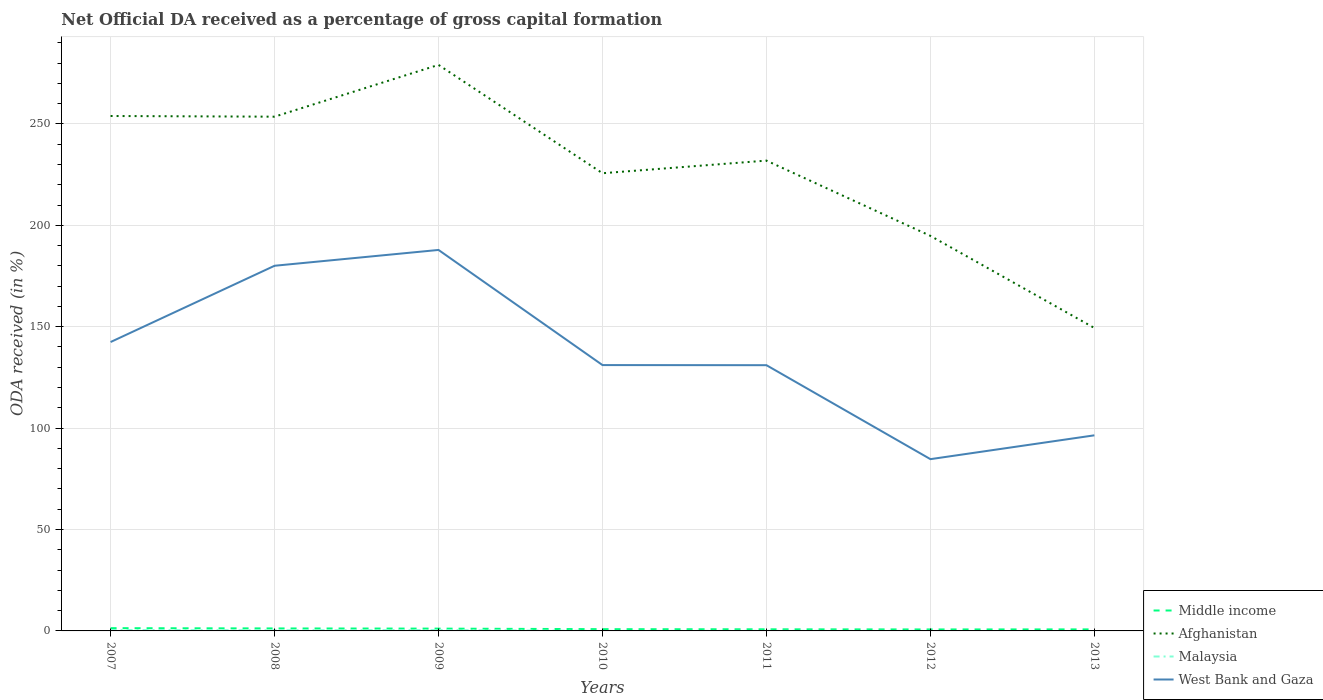Does the line corresponding to Afghanistan intersect with the line corresponding to Malaysia?
Make the answer very short. No. Across all years, what is the maximum net ODA received in Afghanistan?
Make the answer very short. 149.37. What is the total net ODA received in West Bank and Gaza in the graph?
Offer a very short reply. 95.35. What is the difference between the highest and the second highest net ODA received in West Bank and Gaza?
Give a very brief answer. 103.15. What is the difference between the highest and the lowest net ODA received in Malaysia?
Offer a very short reply. 3. Is the net ODA received in Afghanistan strictly greater than the net ODA received in Middle income over the years?
Keep it short and to the point. No. How many lines are there?
Give a very brief answer. 4. How are the legend labels stacked?
Provide a short and direct response. Vertical. What is the title of the graph?
Provide a succinct answer. Net Official DA received as a percentage of gross capital formation. What is the label or title of the X-axis?
Offer a very short reply. Years. What is the label or title of the Y-axis?
Offer a very short reply. ODA received (in %). What is the ODA received (in %) in Middle income in 2007?
Make the answer very short. 1.36. What is the ODA received (in %) in Afghanistan in 2007?
Keep it short and to the point. 253.89. What is the ODA received (in %) in Malaysia in 2007?
Your answer should be very brief. 0.44. What is the ODA received (in %) of West Bank and Gaza in 2007?
Provide a succinct answer. 142.44. What is the ODA received (in %) of Middle income in 2008?
Offer a very short reply. 1.23. What is the ODA received (in %) of Afghanistan in 2008?
Ensure brevity in your answer.  253.56. What is the ODA received (in %) of Malaysia in 2008?
Your response must be concise. 0.31. What is the ODA received (in %) in West Bank and Gaza in 2008?
Give a very brief answer. 180.05. What is the ODA received (in %) of Middle income in 2009?
Make the answer very short. 1.14. What is the ODA received (in %) of Afghanistan in 2009?
Provide a short and direct response. 279.09. What is the ODA received (in %) in Malaysia in 2009?
Give a very brief answer. 0.4. What is the ODA received (in %) of West Bank and Gaza in 2009?
Your response must be concise. 187.84. What is the ODA received (in %) of Middle income in 2010?
Your answer should be compact. 0.87. What is the ODA received (in %) in Afghanistan in 2010?
Your answer should be very brief. 225.67. What is the ODA received (in %) in Malaysia in 2010?
Your response must be concise. 0. What is the ODA received (in %) of West Bank and Gaza in 2010?
Provide a short and direct response. 131.08. What is the ODA received (in %) of Middle income in 2011?
Your answer should be very brief. 0.8. What is the ODA received (in %) in Afghanistan in 2011?
Provide a short and direct response. 231.9. What is the ODA received (in %) in Malaysia in 2011?
Your answer should be very brief. 0.05. What is the ODA received (in %) in West Bank and Gaza in 2011?
Make the answer very short. 131.02. What is the ODA received (in %) in Middle income in 2012?
Provide a succinct answer. 0.73. What is the ODA received (in %) in Afghanistan in 2012?
Provide a succinct answer. 194.79. What is the ODA received (in %) in Malaysia in 2012?
Ensure brevity in your answer.  0.02. What is the ODA received (in %) in West Bank and Gaza in 2012?
Make the answer very short. 84.7. What is the ODA received (in %) of Middle income in 2013?
Provide a succinct answer. 0.76. What is the ODA received (in %) of Afghanistan in 2013?
Offer a terse response. 149.37. What is the ODA received (in %) in West Bank and Gaza in 2013?
Make the answer very short. 96.44. Across all years, what is the maximum ODA received (in %) in Middle income?
Provide a succinct answer. 1.36. Across all years, what is the maximum ODA received (in %) in Afghanistan?
Offer a very short reply. 279.09. Across all years, what is the maximum ODA received (in %) in Malaysia?
Make the answer very short. 0.44. Across all years, what is the maximum ODA received (in %) in West Bank and Gaza?
Provide a succinct answer. 187.84. Across all years, what is the minimum ODA received (in %) of Middle income?
Ensure brevity in your answer.  0.73. Across all years, what is the minimum ODA received (in %) of Afghanistan?
Give a very brief answer. 149.37. Across all years, what is the minimum ODA received (in %) of West Bank and Gaza?
Give a very brief answer. 84.7. What is the total ODA received (in %) of Middle income in the graph?
Provide a short and direct response. 6.88. What is the total ODA received (in %) of Afghanistan in the graph?
Your answer should be compact. 1588.26. What is the total ODA received (in %) of Malaysia in the graph?
Your answer should be very brief. 1.22. What is the total ODA received (in %) of West Bank and Gaza in the graph?
Ensure brevity in your answer.  953.58. What is the difference between the ODA received (in %) in Middle income in 2007 and that in 2008?
Ensure brevity in your answer.  0.13. What is the difference between the ODA received (in %) in Afghanistan in 2007 and that in 2008?
Offer a terse response. 0.33. What is the difference between the ODA received (in %) in Malaysia in 2007 and that in 2008?
Ensure brevity in your answer.  0.13. What is the difference between the ODA received (in %) of West Bank and Gaza in 2007 and that in 2008?
Ensure brevity in your answer.  -37.6. What is the difference between the ODA received (in %) in Middle income in 2007 and that in 2009?
Provide a short and direct response. 0.23. What is the difference between the ODA received (in %) in Afghanistan in 2007 and that in 2009?
Make the answer very short. -25.2. What is the difference between the ODA received (in %) in Malaysia in 2007 and that in 2009?
Give a very brief answer. 0.05. What is the difference between the ODA received (in %) in West Bank and Gaza in 2007 and that in 2009?
Keep it short and to the point. -45.4. What is the difference between the ODA received (in %) of Middle income in 2007 and that in 2010?
Make the answer very short. 0.49. What is the difference between the ODA received (in %) of Afghanistan in 2007 and that in 2010?
Your answer should be very brief. 28.22. What is the difference between the ODA received (in %) in Malaysia in 2007 and that in 2010?
Provide a succinct answer. 0.44. What is the difference between the ODA received (in %) in West Bank and Gaza in 2007 and that in 2010?
Your response must be concise. 11.36. What is the difference between the ODA received (in %) of Middle income in 2007 and that in 2011?
Offer a terse response. 0.57. What is the difference between the ODA received (in %) of Afghanistan in 2007 and that in 2011?
Give a very brief answer. 21.99. What is the difference between the ODA received (in %) of Malaysia in 2007 and that in 2011?
Offer a very short reply. 0.4. What is the difference between the ODA received (in %) of West Bank and Gaza in 2007 and that in 2011?
Provide a succinct answer. 11.42. What is the difference between the ODA received (in %) in Middle income in 2007 and that in 2012?
Make the answer very short. 0.63. What is the difference between the ODA received (in %) of Afghanistan in 2007 and that in 2012?
Your answer should be compact. 59.1. What is the difference between the ODA received (in %) in Malaysia in 2007 and that in 2012?
Offer a very short reply. 0.42. What is the difference between the ODA received (in %) of West Bank and Gaza in 2007 and that in 2012?
Make the answer very short. 57.75. What is the difference between the ODA received (in %) of Middle income in 2007 and that in 2013?
Your response must be concise. 0.6. What is the difference between the ODA received (in %) in Afghanistan in 2007 and that in 2013?
Your response must be concise. 104.52. What is the difference between the ODA received (in %) in West Bank and Gaza in 2007 and that in 2013?
Offer a terse response. 46. What is the difference between the ODA received (in %) of Middle income in 2008 and that in 2009?
Ensure brevity in your answer.  0.09. What is the difference between the ODA received (in %) of Afghanistan in 2008 and that in 2009?
Offer a terse response. -25.53. What is the difference between the ODA received (in %) of Malaysia in 2008 and that in 2009?
Provide a short and direct response. -0.08. What is the difference between the ODA received (in %) in West Bank and Gaza in 2008 and that in 2009?
Keep it short and to the point. -7.8. What is the difference between the ODA received (in %) in Middle income in 2008 and that in 2010?
Make the answer very short. 0.36. What is the difference between the ODA received (in %) in Afghanistan in 2008 and that in 2010?
Your response must be concise. 27.88. What is the difference between the ODA received (in %) in Malaysia in 2008 and that in 2010?
Offer a terse response. 0.31. What is the difference between the ODA received (in %) of West Bank and Gaza in 2008 and that in 2010?
Give a very brief answer. 48.97. What is the difference between the ODA received (in %) of Middle income in 2008 and that in 2011?
Make the answer very short. 0.43. What is the difference between the ODA received (in %) of Afghanistan in 2008 and that in 2011?
Your response must be concise. 21.66. What is the difference between the ODA received (in %) of Malaysia in 2008 and that in 2011?
Keep it short and to the point. 0.27. What is the difference between the ODA received (in %) of West Bank and Gaza in 2008 and that in 2011?
Your answer should be very brief. 49.03. What is the difference between the ODA received (in %) in Middle income in 2008 and that in 2012?
Keep it short and to the point. 0.5. What is the difference between the ODA received (in %) in Afghanistan in 2008 and that in 2012?
Your answer should be compact. 58.77. What is the difference between the ODA received (in %) of Malaysia in 2008 and that in 2012?
Make the answer very short. 0.29. What is the difference between the ODA received (in %) of West Bank and Gaza in 2008 and that in 2012?
Your response must be concise. 95.35. What is the difference between the ODA received (in %) in Middle income in 2008 and that in 2013?
Provide a short and direct response. 0.47. What is the difference between the ODA received (in %) in Afghanistan in 2008 and that in 2013?
Your response must be concise. 104.19. What is the difference between the ODA received (in %) of West Bank and Gaza in 2008 and that in 2013?
Your answer should be compact. 83.61. What is the difference between the ODA received (in %) of Middle income in 2009 and that in 2010?
Ensure brevity in your answer.  0.27. What is the difference between the ODA received (in %) in Afghanistan in 2009 and that in 2010?
Give a very brief answer. 53.42. What is the difference between the ODA received (in %) in Malaysia in 2009 and that in 2010?
Offer a terse response. 0.39. What is the difference between the ODA received (in %) of West Bank and Gaza in 2009 and that in 2010?
Your response must be concise. 56.76. What is the difference between the ODA received (in %) of Middle income in 2009 and that in 2011?
Offer a terse response. 0.34. What is the difference between the ODA received (in %) in Afghanistan in 2009 and that in 2011?
Provide a succinct answer. 47.19. What is the difference between the ODA received (in %) of Malaysia in 2009 and that in 2011?
Your answer should be compact. 0.35. What is the difference between the ODA received (in %) in West Bank and Gaza in 2009 and that in 2011?
Your answer should be compact. 56.82. What is the difference between the ODA received (in %) of Middle income in 2009 and that in 2012?
Provide a succinct answer. 0.4. What is the difference between the ODA received (in %) in Afghanistan in 2009 and that in 2012?
Offer a very short reply. 84.3. What is the difference between the ODA received (in %) of Malaysia in 2009 and that in 2012?
Your answer should be very brief. 0.38. What is the difference between the ODA received (in %) in West Bank and Gaza in 2009 and that in 2012?
Give a very brief answer. 103.15. What is the difference between the ODA received (in %) of Middle income in 2009 and that in 2013?
Your answer should be compact. 0.38. What is the difference between the ODA received (in %) of Afghanistan in 2009 and that in 2013?
Provide a succinct answer. 129.72. What is the difference between the ODA received (in %) of West Bank and Gaza in 2009 and that in 2013?
Offer a terse response. 91.4. What is the difference between the ODA received (in %) in Middle income in 2010 and that in 2011?
Your answer should be very brief. 0.07. What is the difference between the ODA received (in %) of Afghanistan in 2010 and that in 2011?
Your response must be concise. -6.22. What is the difference between the ODA received (in %) in Malaysia in 2010 and that in 2011?
Your answer should be very brief. -0.04. What is the difference between the ODA received (in %) of West Bank and Gaza in 2010 and that in 2011?
Provide a succinct answer. 0.06. What is the difference between the ODA received (in %) in Middle income in 2010 and that in 2012?
Give a very brief answer. 0.14. What is the difference between the ODA received (in %) in Afghanistan in 2010 and that in 2012?
Your response must be concise. 30.89. What is the difference between the ODA received (in %) of Malaysia in 2010 and that in 2012?
Make the answer very short. -0.02. What is the difference between the ODA received (in %) of West Bank and Gaza in 2010 and that in 2012?
Keep it short and to the point. 46.38. What is the difference between the ODA received (in %) of Middle income in 2010 and that in 2013?
Ensure brevity in your answer.  0.11. What is the difference between the ODA received (in %) of Afghanistan in 2010 and that in 2013?
Provide a short and direct response. 76.3. What is the difference between the ODA received (in %) in West Bank and Gaza in 2010 and that in 2013?
Keep it short and to the point. 34.64. What is the difference between the ODA received (in %) in Middle income in 2011 and that in 2012?
Your response must be concise. 0.06. What is the difference between the ODA received (in %) of Afghanistan in 2011 and that in 2012?
Ensure brevity in your answer.  37.11. What is the difference between the ODA received (in %) in Malaysia in 2011 and that in 2012?
Your answer should be very brief. 0.03. What is the difference between the ODA received (in %) in West Bank and Gaza in 2011 and that in 2012?
Provide a succinct answer. 46.32. What is the difference between the ODA received (in %) in Middle income in 2011 and that in 2013?
Keep it short and to the point. 0.04. What is the difference between the ODA received (in %) in Afghanistan in 2011 and that in 2013?
Offer a terse response. 82.53. What is the difference between the ODA received (in %) in West Bank and Gaza in 2011 and that in 2013?
Keep it short and to the point. 34.58. What is the difference between the ODA received (in %) of Middle income in 2012 and that in 2013?
Make the answer very short. -0.03. What is the difference between the ODA received (in %) in Afghanistan in 2012 and that in 2013?
Give a very brief answer. 45.41. What is the difference between the ODA received (in %) of West Bank and Gaza in 2012 and that in 2013?
Your answer should be very brief. -11.75. What is the difference between the ODA received (in %) in Middle income in 2007 and the ODA received (in %) in Afghanistan in 2008?
Your answer should be very brief. -252.19. What is the difference between the ODA received (in %) of Middle income in 2007 and the ODA received (in %) of Malaysia in 2008?
Give a very brief answer. 1.05. What is the difference between the ODA received (in %) in Middle income in 2007 and the ODA received (in %) in West Bank and Gaza in 2008?
Give a very brief answer. -178.69. What is the difference between the ODA received (in %) of Afghanistan in 2007 and the ODA received (in %) of Malaysia in 2008?
Keep it short and to the point. 253.58. What is the difference between the ODA received (in %) of Afghanistan in 2007 and the ODA received (in %) of West Bank and Gaza in 2008?
Keep it short and to the point. 73.84. What is the difference between the ODA received (in %) in Malaysia in 2007 and the ODA received (in %) in West Bank and Gaza in 2008?
Ensure brevity in your answer.  -179.61. What is the difference between the ODA received (in %) in Middle income in 2007 and the ODA received (in %) in Afghanistan in 2009?
Offer a very short reply. -277.73. What is the difference between the ODA received (in %) of Middle income in 2007 and the ODA received (in %) of Malaysia in 2009?
Your answer should be very brief. 0.97. What is the difference between the ODA received (in %) of Middle income in 2007 and the ODA received (in %) of West Bank and Gaza in 2009?
Your answer should be very brief. -186.48. What is the difference between the ODA received (in %) in Afghanistan in 2007 and the ODA received (in %) in Malaysia in 2009?
Your response must be concise. 253.49. What is the difference between the ODA received (in %) of Afghanistan in 2007 and the ODA received (in %) of West Bank and Gaza in 2009?
Give a very brief answer. 66.04. What is the difference between the ODA received (in %) in Malaysia in 2007 and the ODA received (in %) in West Bank and Gaza in 2009?
Your answer should be compact. -187.4. What is the difference between the ODA received (in %) in Middle income in 2007 and the ODA received (in %) in Afghanistan in 2010?
Your answer should be very brief. -224.31. What is the difference between the ODA received (in %) in Middle income in 2007 and the ODA received (in %) in Malaysia in 2010?
Your response must be concise. 1.36. What is the difference between the ODA received (in %) of Middle income in 2007 and the ODA received (in %) of West Bank and Gaza in 2010?
Provide a short and direct response. -129.72. What is the difference between the ODA received (in %) in Afghanistan in 2007 and the ODA received (in %) in Malaysia in 2010?
Your response must be concise. 253.88. What is the difference between the ODA received (in %) in Afghanistan in 2007 and the ODA received (in %) in West Bank and Gaza in 2010?
Give a very brief answer. 122.81. What is the difference between the ODA received (in %) of Malaysia in 2007 and the ODA received (in %) of West Bank and Gaza in 2010?
Your response must be concise. -130.64. What is the difference between the ODA received (in %) of Middle income in 2007 and the ODA received (in %) of Afghanistan in 2011?
Offer a terse response. -230.53. What is the difference between the ODA received (in %) in Middle income in 2007 and the ODA received (in %) in Malaysia in 2011?
Give a very brief answer. 1.32. What is the difference between the ODA received (in %) of Middle income in 2007 and the ODA received (in %) of West Bank and Gaza in 2011?
Your answer should be very brief. -129.66. What is the difference between the ODA received (in %) in Afghanistan in 2007 and the ODA received (in %) in Malaysia in 2011?
Offer a very short reply. 253.84. What is the difference between the ODA received (in %) in Afghanistan in 2007 and the ODA received (in %) in West Bank and Gaza in 2011?
Make the answer very short. 122.87. What is the difference between the ODA received (in %) in Malaysia in 2007 and the ODA received (in %) in West Bank and Gaza in 2011?
Your answer should be compact. -130.58. What is the difference between the ODA received (in %) of Middle income in 2007 and the ODA received (in %) of Afghanistan in 2012?
Make the answer very short. -193.42. What is the difference between the ODA received (in %) in Middle income in 2007 and the ODA received (in %) in Malaysia in 2012?
Ensure brevity in your answer.  1.34. What is the difference between the ODA received (in %) of Middle income in 2007 and the ODA received (in %) of West Bank and Gaza in 2012?
Your answer should be very brief. -83.33. What is the difference between the ODA received (in %) of Afghanistan in 2007 and the ODA received (in %) of Malaysia in 2012?
Provide a short and direct response. 253.87. What is the difference between the ODA received (in %) of Afghanistan in 2007 and the ODA received (in %) of West Bank and Gaza in 2012?
Your response must be concise. 169.19. What is the difference between the ODA received (in %) of Malaysia in 2007 and the ODA received (in %) of West Bank and Gaza in 2012?
Make the answer very short. -84.26. What is the difference between the ODA received (in %) of Middle income in 2007 and the ODA received (in %) of Afghanistan in 2013?
Ensure brevity in your answer.  -148.01. What is the difference between the ODA received (in %) of Middle income in 2007 and the ODA received (in %) of West Bank and Gaza in 2013?
Your response must be concise. -95.08. What is the difference between the ODA received (in %) of Afghanistan in 2007 and the ODA received (in %) of West Bank and Gaza in 2013?
Offer a very short reply. 157.45. What is the difference between the ODA received (in %) of Malaysia in 2007 and the ODA received (in %) of West Bank and Gaza in 2013?
Give a very brief answer. -96. What is the difference between the ODA received (in %) in Middle income in 2008 and the ODA received (in %) in Afghanistan in 2009?
Your response must be concise. -277.86. What is the difference between the ODA received (in %) of Middle income in 2008 and the ODA received (in %) of Malaysia in 2009?
Ensure brevity in your answer.  0.83. What is the difference between the ODA received (in %) of Middle income in 2008 and the ODA received (in %) of West Bank and Gaza in 2009?
Make the answer very short. -186.62. What is the difference between the ODA received (in %) of Afghanistan in 2008 and the ODA received (in %) of Malaysia in 2009?
Provide a succinct answer. 253.16. What is the difference between the ODA received (in %) of Afghanistan in 2008 and the ODA received (in %) of West Bank and Gaza in 2009?
Ensure brevity in your answer.  65.71. What is the difference between the ODA received (in %) of Malaysia in 2008 and the ODA received (in %) of West Bank and Gaza in 2009?
Your answer should be very brief. -187.53. What is the difference between the ODA received (in %) of Middle income in 2008 and the ODA received (in %) of Afghanistan in 2010?
Keep it short and to the point. -224.44. What is the difference between the ODA received (in %) of Middle income in 2008 and the ODA received (in %) of Malaysia in 2010?
Provide a succinct answer. 1.22. What is the difference between the ODA received (in %) in Middle income in 2008 and the ODA received (in %) in West Bank and Gaza in 2010?
Provide a succinct answer. -129.85. What is the difference between the ODA received (in %) in Afghanistan in 2008 and the ODA received (in %) in Malaysia in 2010?
Give a very brief answer. 253.55. What is the difference between the ODA received (in %) in Afghanistan in 2008 and the ODA received (in %) in West Bank and Gaza in 2010?
Offer a very short reply. 122.48. What is the difference between the ODA received (in %) of Malaysia in 2008 and the ODA received (in %) of West Bank and Gaza in 2010?
Offer a very short reply. -130.77. What is the difference between the ODA received (in %) in Middle income in 2008 and the ODA received (in %) in Afghanistan in 2011?
Make the answer very short. -230.67. What is the difference between the ODA received (in %) in Middle income in 2008 and the ODA received (in %) in Malaysia in 2011?
Make the answer very short. 1.18. What is the difference between the ODA received (in %) of Middle income in 2008 and the ODA received (in %) of West Bank and Gaza in 2011?
Provide a short and direct response. -129.79. What is the difference between the ODA received (in %) in Afghanistan in 2008 and the ODA received (in %) in Malaysia in 2011?
Your response must be concise. 253.51. What is the difference between the ODA received (in %) in Afghanistan in 2008 and the ODA received (in %) in West Bank and Gaza in 2011?
Your response must be concise. 122.53. What is the difference between the ODA received (in %) in Malaysia in 2008 and the ODA received (in %) in West Bank and Gaza in 2011?
Ensure brevity in your answer.  -130.71. What is the difference between the ODA received (in %) of Middle income in 2008 and the ODA received (in %) of Afghanistan in 2012?
Your response must be concise. -193.56. What is the difference between the ODA received (in %) in Middle income in 2008 and the ODA received (in %) in Malaysia in 2012?
Your answer should be very brief. 1.21. What is the difference between the ODA received (in %) of Middle income in 2008 and the ODA received (in %) of West Bank and Gaza in 2012?
Ensure brevity in your answer.  -83.47. What is the difference between the ODA received (in %) of Afghanistan in 2008 and the ODA received (in %) of Malaysia in 2012?
Provide a short and direct response. 253.54. What is the difference between the ODA received (in %) in Afghanistan in 2008 and the ODA received (in %) in West Bank and Gaza in 2012?
Your answer should be compact. 168.86. What is the difference between the ODA received (in %) in Malaysia in 2008 and the ODA received (in %) in West Bank and Gaza in 2012?
Provide a succinct answer. -84.38. What is the difference between the ODA received (in %) in Middle income in 2008 and the ODA received (in %) in Afghanistan in 2013?
Your answer should be compact. -148.14. What is the difference between the ODA received (in %) of Middle income in 2008 and the ODA received (in %) of West Bank and Gaza in 2013?
Your answer should be compact. -95.21. What is the difference between the ODA received (in %) in Afghanistan in 2008 and the ODA received (in %) in West Bank and Gaza in 2013?
Make the answer very short. 157.11. What is the difference between the ODA received (in %) of Malaysia in 2008 and the ODA received (in %) of West Bank and Gaza in 2013?
Your response must be concise. -96.13. What is the difference between the ODA received (in %) of Middle income in 2009 and the ODA received (in %) of Afghanistan in 2010?
Offer a very short reply. -224.54. What is the difference between the ODA received (in %) of Middle income in 2009 and the ODA received (in %) of Malaysia in 2010?
Offer a very short reply. 1.13. What is the difference between the ODA received (in %) of Middle income in 2009 and the ODA received (in %) of West Bank and Gaza in 2010?
Your answer should be very brief. -129.94. What is the difference between the ODA received (in %) in Afghanistan in 2009 and the ODA received (in %) in Malaysia in 2010?
Offer a very short reply. 279.09. What is the difference between the ODA received (in %) in Afghanistan in 2009 and the ODA received (in %) in West Bank and Gaza in 2010?
Provide a short and direct response. 148.01. What is the difference between the ODA received (in %) in Malaysia in 2009 and the ODA received (in %) in West Bank and Gaza in 2010?
Offer a very short reply. -130.68. What is the difference between the ODA received (in %) in Middle income in 2009 and the ODA received (in %) in Afghanistan in 2011?
Your answer should be very brief. -230.76. What is the difference between the ODA received (in %) of Middle income in 2009 and the ODA received (in %) of Malaysia in 2011?
Ensure brevity in your answer.  1.09. What is the difference between the ODA received (in %) in Middle income in 2009 and the ODA received (in %) in West Bank and Gaza in 2011?
Make the answer very short. -129.89. What is the difference between the ODA received (in %) of Afghanistan in 2009 and the ODA received (in %) of Malaysia in 2011?
Ensure brevity in your answer.  279.04. What is the difference between the ODA received (in %) in Afghanistan in 2009 and the ODA received (in %) in West Bank and Gaza in 2011?
Offer a terse response. 148.07. What is the difference between the ODA received (in %) of Malaysia in 2009 and the ODA received (in %) of West Bank and Gaza in 2011?
Your answer should be very brief. -130.62. What is the difference between the ODA received (in %) in Middle income in 2009 and the ODA received (in %) in Afghanistan in 2012?
Give a very brief answer. -193.65. What is the difference between the ODA received (in %) of Middle income in 2009 and the ODA received (in %) of Malaysia in 2012?
Make the answer very short. 1.12. What is the difference between the ODA received (in %) of Middle income in 2009 and the ODA received (in %) of West Bank and Gaza in 2012?
Make the answer very short. -83.56. What is the difference between the ODA received (in %) in Afghanistan in 2009 and the ODA received (in %) in Malaysia in 2012?
Your answer should be compact. 279.07. What is the difference between the ODA received (in %) in Afghanistan in 2009 and the ODA received (in %) in West Bank and Gaza in 2012?
Your answer should be very brief. 194.39. What is the difference between the ODA received (in %) of Malaysia in 2009 and the ODA received (in %) of West Bank and Gaza in 2012?
Give a very brief answer. -84.3. What is the difference between the ODA received (in %) in Middle income in 2009 and the ODA received (in %) in Afghanistan in 2013?
Give a very brief answer. -148.24. What is the difference between the ODA received (in %) in Middle income in 2009 and the ODA received (in %) in West Bank and Gaza in 2013?
Offer a very short reply. -95.31. What is the difference between the ODA received (in %) in Afghanistan in 2009 and the ODA received (in %) in West Bank and Gaza in 2013?
Your answer should be compact. 182.65. What is the difference between the ODA received (in %) of Malaysia in 2009 and the ODA received (in %) of West Bank and Gaza in 2013?
Your response must be concise. -96.05. What is the difference between the ODA received (in %) in Middle income in 2010 and the ODA received (in %) in Afghanistan in 2011?
Give a very brief answer. -231.03. What is the difference between the ODA received (in %) of Middle income in 2010 and the ODA received (in %) of Malaysia in 2011?
Provide a succinct answer. 0.82. What is the difference between the ODA received (in %) in Middle income in 2010 and the ODA received (in %) in West Bank and Gaza in 2011?
Give a very brief answer. -130.15. What is the difference between the ODA received (in %) of Afghanistan in 2010 and the ODA received (in %) of Malaysia in 2011?
Give a very brief answer. 225.63. What is the difference between the ODA received (in %) of Afghanistan in 2010 and the ODA received (in %) of West Bank and Gaza in 2011?
Keep it short and to the point. 94.65. What is the difference between the ODA received (in %) in Malaysia in 2010 and the ODA received (in %) in West Bank and Gaza in 2011?
Your answer should be very brief. -131.02. What is the difference between the ODA received (in %) in Middle income in 2010 and the ODA received (in %) in Afghanistan in 2012?
Ensure brevity in your answer.  -193.92. What is the difference between the ODA received (in %) of Middle income in 2010 and the ODA received (in %) of Malaysia in 2012?
Your answer should be very brief. 0.85. What is the difference between the ODA received (in %) in Middle income in 2010 and the ODA received (in %) in West Bank and Gaza in 2012?
Your answer should be very brief. -83.83. What is the difference between the ODA received (in %) of Afghanistan in 2010 and the ODA received (in %) of Malaysia in 2012?
Your answer should be very brief. 225.65. What is the difference between the ODA received (in %) in Afghanistan in 2010 and the ODA received (in %) in West Bank and Gaza in 2012?
Make the answer very short. 140.98. What is the difference between the ODA received (in %) in Malaysia in 2010 and the ODA received (in %) in West Bank and Gaza in 2012?
Make the answer very short. -84.69. What is the difference between the ODA received (in %) of Middle income in 2010 and the ODA received (in %) of Afghanistan in 2013?
Make the answer very short. -148.5. What is the difference between the ODA received (in %) in Middle income in 2010 and the ODA received (in %) in West Bank and Gaza in 2013?
Offer a very short reply. -95.57. What is the difference between the ODA received (in %) in Afghanistan in 2010 and the ODA received (in %) in West Bank and Gaza in 2013?
Offer a terse response. 129.23. What is the difference between the ODA received (in %) in Malaysia in 2010 and the ODA received (in %) in West Bank and Gaza in 2013?
Ensure brevity in your answer.  -96.44. What is the difference between the ODA received (in %) of Middle income in 2011 and the ODA received (in %) of Afghanistan in 2012?
Your answer should be compact. -193.99. What is the difference between the ODA received (in %) in Middle income in 2011 and the ODA received (in %) in Malaysia in 2012?
Your response must be concise. 0.78. What is the difference between the ODA received (in %) in Middle income in 2011 and the ODA received (in %) in West Bank and Gaza in 2012?
Your response must be concise. -83.9. What is the difference between the ODA received (in %) in Afghanistan in 2011 and the ODA received (in %) in Malaysia in 2012?
Make the answer very short. 231.88. What is the difference between the ODA received (in %) in Afghanistan in 2011 and the ODA received (in %) in West Bank and Gaza in 2012?
Offer a terse response. 147.2. What is the difference between the ODA received (in %) in Malaysia in 2011 and the ODA received (in %) in West Bank and Gaza in 2012?
Your answer should be compact. -84.65. What is the difference between the ODA received (in %) in Middle income in 2011 and the ODA received (in %) in Afghanistan in 2013?
Your answer should be compact. -148.57. What is the difference between the ODA received (in %) of Middle income in 2011 and the ODA received (in %) of West Bank and Gaza in 2013?
Your answer should be compact. -95.65. What is the difference between the ODA received (in %) in Afghanistan in 2011 and the ODA received (in %) in West Bank and Gaza in 2013?
Your answer should be compact. 135.45. What is the difference between the ODA received (in %) of Malaysia in 2011 and the ODA received (in %) of West Bank and Gaza in 2013?
Make the answer very short. -96.4. What is the difference between the ODA received (in %) of Middle income in 2012 and the ODA received (in %) of Afghanistan in 2013?
Offer a very short reply. -148.64. What is the difference between the ODA received (in %) in Middle income in 2012 and the ODA received (in %) in West Bank and Gaza in 2013?
Keep it short and to the point. -95.71. What is the difference between the ODA received (in %) in Afghanistan in 2012 and the ODA received (in %) in West Bank and Gaza in 2013?
Ensure brevity in your answer.  98.34. What is the difference between the ODA received (in %) of Malaysia in 2012 and the ODA received (in %) of West Bank and Gaza in 2013?
Make the answer very short. -96.42. What is the average ODA received (in %) in Middle income per year?
Your answer should be very brief. 0.98. What is the average ODA received (in %) in Afghanistan per year?
Give a very brief answer. 226.89. What is the average ODA received (in %) in Malaysia per year?
Offer a very short reply. 0.17. What is the average ODA received (in %) of West Bank and Gaza per year?
Provide a succinct answer. 136.23. In the year 2007, what is the difference between the ODA received (in %) of Middle income and ODA received (in %) of Afghanistan?
Make the answer very short. -252.53. In the year 2007, what is the difference between the ODA received (in %) of Middle income and ODA received (in %) of Malaysia?
Offer a very short reply. 0.92. In the year 2007, what is the difference between the ODA received (in %) in Middle income and ODA received (in %) in West Bank and Gaza?
Offer a very short reply. -141.08. In the year 2007, what is the difference between the ODA received (in %) in Afghanistan and ODA received (in %) in Malaysia?
Keep it short and to the point. 253.45. In the year 2007, what is the difference between the ODA received (in %) of Afghanistan and ODA received (in %) of West Bank and Gaza?
Give a very brief answer. 111.44. In the year 2007, what is the difference between the ODA received (in %) in Malaysia and ODA received (in %) in West Bank and Gaza?
Provide a succinct answer. -142. In the year 2008, what is the difference between the ODA received (in %) of Middle income and ODA received (in %) of Afghanistan?
Ensure brevity in your answer.  -252.33. In the year 2008, what is the difference between the ODA received (in %) in Middle income and ODA received (in %) in Malaysia?
Your answer should be compact. 0.92. In the year 2008, what is the difference between the ODA received (in %) of Middle income and ODA received (in %) of West Bank and Gaza?
Make the answer very short. -178.82. In the year 2008, what is the difference between the ODA received (in %) of Afghanistan and ODA received (in %) of Malaysia?
Your answer should be compact. 253.24. In the year 2008, what is the difference between the ODA received (in %) of Afghanistan and ODA received (in %) of West Bank and Gaza?
Keep it short and to the point. 73.51. In the year 2008, what is the difference between the ODA received (in %) of Malaysia and ODA received (in %) of West Bank and Gaza?
Your answer should be compact. -179.74. In the year 2009, what is the difference between the ODA received (in %) in Middle income and ODA received (in %) in Afghanistan?
Your response must be concise. -277.95. In the year 2009, what is the difference between the ODA received (in %) of Middle income and ODA received (in %) of Malaysia?
Offer a terse response. 0.74. In the year 2009, what is the difference between the ODA received (in %) in Middle income and ODA received (in %) in West Bank and Gaza?
Provide a succinct answer. -186.71. In the year 2009, what is the difference between the ODA received (in %) in Afghanistan and ODA received (in %) in Malaysia?
Your response must be concise. 278.69. In the year 2009, what is the difference between the ODA received (in %) in Afghanistan and ODA received (in %) in West Bank and Gaza?
Offer a very short reply. 91.25. In the year 2009, what is the difference between the ODA received (in %) in Malaysia and ODA received (in %) in West Bank and Gaza?
Keep it short and to the point. -187.45. In the year 2010, what is the difference between the ODA received (in %) in Middle income and ODA received (in %) in Afghanistan?
Give a very brief answer. -224.8. In the year 2010, what is the difference between the ODA received (in %) of Middle income and ODA received (in %) of Malaysia?
Your response must be concise. 0.87. In the year 2010, what is the difference between the ODA received (in %) of Middle income and ODA received (in %) of West Bank and Gaza?
Provide a short and direct response. -130.21. In the year 2010, what is the difference between the ODA received (in %) of Afghanistan and ODA received (in %) of Malaysia?
Give a very brief answer. 225.67. In the year 2010, what is the difference between the ODA received (in %) in Afghanistan and ODA received (in %) in West Bank and Gaza?
Your answer should be very brief. 94.59. In the year 2010, what is the difference between the ODA received (in %) in Malaysia and ODA received (in %) in West Bank and Gaza?
Your answer should be very brief. -131.08. In the year 2011, what is the difference between the ODA received (in %) in Middle income and ODA received (in %) in Afghanistan?
Your answer should be compact. -231.1. In the year 2011, what is the difference between the ODA received (in %) in Middle income and ODA received (in %) in Malaysia?
Your response must be concise. 0.75. In the year 2011, what is the difference between the ODA received (in %) of Middle income and ODA received (in %) of West Bank and Gaza?
Keep it short and to the point. -130.23. In the year 2011, what is the difference between the ODA received (in %) of Afghanistan and ODA received (in %) of Malaysia?
Give a very brief answer. 231.85. In the year 2011, what is the difference between the ODA received (in %) of Afghanistan and ODA received (in %) of West Bank and Gaza?
Make the answer very short. 100.88. In the year 2011, what is the difference between the ODA received (in %) of Malaysia and ODA received (in %) of West Bank and Gaza?
Your response must be concise. -130.97. In the year 2012, what is the difference between the ODA received (in %) of Middle income and ODA received (in %) of Afghanistan?
Offer a terse response. -194.05. In the year 2012, what is the difference between the ODA received (in %) in Middle income and ODA received (in %) in Malaysia?
Offer a very short reply. 0.71. In the year 2012, what is the difference between the ODA received (in %) in Middle income and ODA received (in %) in West Bank and Gaza?
Give a very brief answer. -83.97. In the year 2012, what is the difference between the ODA received (in %) of Afghanistan and ODA received (in %) of Malaysia?
Make the answer very short. 194.77. In the year 2012, what is the difference between the ODA received (in %) in Afghanistan and ODA received (in %) in West Bank and Gaza?
Offer a very short reply. 110.09. In the year 2012, what is the difference between the ODA received (in %) in Malaysia and ODA received (in %) in West Bank and Gaza?
Provide a succinct answer. -84.68. In the year 2013, what is the difference between the ODA received (in %) of Middle income and ODA received (in %) of Afghanistan?
Your response must be concise. -148.61. In the year 2013, what is the difference between the ODA received (in %) in Middle income and ODA received (in %) in West Bank and Gaza?
Provide a short and direct response. -95.68. In the year 2013, what is the difference between the ODA received (in %) of Afghanistan and ODA received (in %) of West Bank and Gaza?
Provide a short and direct response. 52.93. What is the ratio of the ODA received (in %) of Middle income in 2007 to that in 2008?
Offer a terse response. 1.11. What is the ratio of the ODA received (in %) in Afghanistan in 2007 to that in 2008?
Ensure brevity in your answer.  1. What is the ratio of the ODA received (in %) in Malaysia in 2007 to that in 2008?
Ensure brevity in your answer.  1.42. What is the ratio of the ODA received (in %) of West Bank and Gaza in 2007 to that in 2008?
Your answer should be compact. 0.79. What is the ratio of the ODA received (in %) of Middle income in 2007 to that in 2009?
Keep it short and to the point. 1.2. What is the ratio of the ODA received (in %) of Afghanistan in 2007 to that in 2009?
Give a very brief answer. 0.91. What is the ratio of the ODA received (in %) of Malaysia in 2007 to that in 2009?
Your answer should be compact. 1.11. What is the ratio of the ODA received (in %) of West Bank and Gaza in 2007 to that in 2009?
Provide a succinct answer. 0.76. What is the ratio of the ODA received (in %) of Middle income in 2007 to that in 2010?
Make the answer very short. 1.57. What is the ratio of the ODA received (in %) in Malaysia in 2007 to that in 2010?
Offer a very short reply. 127.88. What is the ratio of the ODA received (in %) of West Bank and Gaza in 2007 to that in 2010?
Your answer should be very brief. 1.09. What is the ratio of the ODA received (in %) in Middle income in 2007 to that in 2011?
Provide a short and direct response. 1.71. What is the ratio of the ODA received (in %) of Afghanistan in 2007 to that in 2011?
Your response must be concise. 1.09. What is the ratio of the ODA received (in %) of Malaysia in 2007 to that in 2011?
Give a very brief answer. 9.51. What is the ratio of the ODA received (in %) in West Bank and Gaza in 2007 to that in 2011?
Your response must be concise. 1.09. What is the ratio of the ODA received (in %) of Middle income in 2007 to that in 2012?
Provide a succinct answer. 1.86. What is the ratio of the ODA received (in %) of Afghanistan in 2007 to that in 2012?
Make the answer very short. 1.3. What is the ratio of the ODA received (in %) of Malaysia in 2007 to that in 2012?
Your answer should be very brief. 23.27. What is the ratio of the ODA received (in %) of West Bank and Gaza in 2007 to that in 2012?
Offer a terse response. 1.68. What is the ratio of the ODA received (in %) in Middle income in 2007 to that in 2013?
Your answer should be compact. 1.79. What is the ratio of the ODA received (in %) of Afghanistan in 2007 to that in 2013?
Your answer should be compact. 1.7. What is the ratio of the ODA received (in %) in West Bank and Gaza in 2007 to that in 2013?
Your answer should be compact. 1.48. What is the ratio of the ODA received (in %) of Middle income in 2008 to that in 2009?
Your response must be concise. 1.08. What is the ratio of the ODA received (in %) in Afghanistan in 2008 to that in 2009?
Your answer should be very brief. 0.91. What is the ratio of the ODA received (in %) in Malaysia in 2008 to that in 2009?
Your answer should be compact. 0.79. What is the ratio of the ODA received (in %) in West Bank and Gaza in 2008 to that in 2009?
Make the answer very short. 0.96. What is the ratio of the ODA received (in %) in Middle income in 2008 to that in 2010?
Ensure brevity in your answer.  1.41. What is the ratio of the ODA received (in %) in Afghanistan in 2008 to that in 2010?
Your answer should be very brief. 1.12. What is the ratio of the ODA received (in %) of Malaysia in 2008 to that in 2010?
Your response must be concise. 90.32. What is the ratio of the ODA received (in %) of West Bank and Gaza in 2008 to that in 2010?
Offer a terse response. 1.37. What is the ratio of the ODA received (in %) in Middle income in 2008 to that in 2011?
Provide a succinct answer. 1.54. What is the ratio of the ODA received (in %) in Afghanistan in 2008 to that in 2011?
Offer a very short reply. 1.09. What is the ratio of the ODA received (in %) in Malaysia in 2008 to that in 2011?
Offer a very short reply. 6.71. What is the ratio of the ODA received (in %) in West Bank and Gaza in 2008 to that in 2011?
Provide a short and direct response. 1.37. What is the ratio of the ODA received (in %) in Middle income in 2008 to that in 2012?
Ensure brevity in your answer.  1.68. What is the ratio of the ODA received (in %) in Afghanistan in 2008 to that in 2012?
Provide a short and direct response. 1.3. What is the ratio of the ODA received (in %) in Malaysia in 2008 to that in 2012?
Ensure brevity in your answer.  16.43. What is the ratio of the ODA received (in %) in West Bank and Gaza in 2008 to that in 2012?
Your answer should be very brief. 2.13. What is the ratio of the ODA received (in %) of Middle income in 2008 to that in 2013?
Give a very brief answer. 1.62. What is the ratio of the ODA received (in %) of Afghanistan in 2008 to that in 2013?
Keep it short and to the point. 1.7. What is the ratio of the ODA received (in %) in West Bank and Gaza in 2008 to that in 2013?
Provide a short and direct response. 1.87. What is the ratio of the ODA received (in %) in Middle income in 2009 to that in 2010?
Keep it short and to the point. 1.3. What is the ratio of the ODA received (in %) of Afghanistan in 2009 to that in 2010?
Your answer should be very brief. 1.24. What is the ratio of the ODA received (in %) of Malaysia in 2009 to that in 2010?
Keep it short and to the point. 114.73. What is the ratio of the ODA received (in %) in West Bank and Gaza in 2009 to that in 2010?
Your response must be concise. 1.43. What is the ratio of the ODA received (in %) in Middle income in 2009 to that in 2011?
Keep it short and to the point. 1.43. What is the ratio of the ODA received (in %) in Afghanistan in 2009 to that in 2011?
Ensure brevity in your answer.  1.2. What is the ratio of the ODA received (in %) of Malaysia in 2009 to that in 2011?
Your answer should be very brief. 8.53. What is the ratio of the ODA received (in %) of West Bank and Gaza in 2009 to that in 2011?
Ensure brevity in your answer.  1.43. What is the ratio of the ODA received (in %) in Middle income in 2009 to that in 2012?
Keep it short and to the point. 1.55. What is the ratio of the ODA received (in %) in Afghanistan in 2009 to that in 2012?
Ensure brevity in your answer.  1.43. What is the ratio of the ODA received (in %) of Malaysia in 2009 to that in 2012?
Your answer should be very brief. 20.88. What is the ratio of the ODA received (in %) in West Bank and Gaza in 2009 to that in 2012?
Offer a very short reply. 2.22. What is the ratio of the ODA received (in %) of Middle income in 2009 to that in 2013?
Provide a short and direct response. 1.5. What is the ratio of the ODA received (in %) in Afghanistan in 2009 to that in 2013?
Offer a terse response. 1.87. What is the ratio of the ODA received (in %) of West Bank and Gaza in 2009 to that in 2013?
Your response must be concise. 1.95. What is the ratio of the ODA received (in %) of Middle income in 2010 to that in 2011?
Provide a succinct answer. 1.09. What is the ratio of the ODA received (in %) in Afghanistan in 2010 to that in 2011?
Provide a short and direct response. 0.97. What is the ratio of the ODA received (in %) in Malaysia in 2010 to that in 2011?
Ensure brevity in your answer.  0.07. What is the ratio of the ODA received (in %) of Middle income in 2010 to that in 2012?
Offer a terse response. 1.19. What is the ratio of the ODA received (in %) in Afghanistan in 2010 to that in 2012?
Provide a short and direct response. 1.16. What is the ratio of the ODA received (in %) of Malaysia in 2010 to that in 2012?
Your answer should be very brief. 0.18. What is the ratio of the ODA received (in %) in West Bank and Gaza in 2010 to that in 2012?
Provide a short and direct response. 1.55. What is the ratio of the ODA received (in %) in Middle income in 2010 to that in 2013?
Make the answer very short. 1.15. What is the ratio of the ODA received (in %) of Afghanistan in 2010 to that in 2013?
Your answer should be compact. 1.51. What is the ratio of the ODA received (in %) of West Bank and Gaza in 2010 to that in 2013?
Offer a terse response. 1.36. What is the ratio of the ODA received (in %) in Middle income in 2011 to that in 2012?
Give a very brief answer. 1.09. What is the ratio of the ODA received (in %) in Afghanistan in 2011 to that in 2012?
Ensure brevity in your answer.  1.19. What is the ratio of the ODA received (in %) in Malaysia in 2011 to that in 2012?
Offer a very short reply. 2.45. What is the ratio of the ODA received (in %) in West Bank and Gaza in 2011 to that in 2012?
Your answer should be compact. 1.55. What is the ratio of the ODA received (in %) in Middle income in 2011 to that in 2013?
Provide a succinct answer. 1.05. What is the ratio of the ODA received (in %) in Afghanistan in 2011 to that in 2013?
Keep it short and to the point. 1.55. What is the ratio of the ODA received (in %) in West Bank and Gaza in 2011 to that in 2013?
Your answer should be compact. 1.36. What is the ratio of the ODA received (in %) in Middle income in 2012 to that in 2013?
Your answer should be very brief. 0.96. What is the ratio of the ODA received (in %) in Afghanistan in 2012 to that in 2013?
Offer a very short reply. 1.3. What is the ratio of the ODA received (in %) in West Bank and Gaza in 2012 to that in 2013?
Make the answer very short. 0.88. What is the difference between the highest and the second highest ODA received (in %) of Middle income?
Provide a succinct answer. 0.13. What is the difference between the highest and the second highest ODA received (in %) in Afghanistan?
Provide a succinct answer. 25.2. What is the difference between the highest and the second highest ODA received (in %) of Malaysia?
Ensure brevity in your answer.  0.05. What is the difference between the highest and the second highest ODA received (in %) of West Bank and Gaza?
Provide a succinct answer. 7.8. What is the difference between the highest and the lowest ODA received (in %) in Middle income?
Your answer should be very brief. 0.63. What is the difference between the highest and the lowest ODA received (in %) in Afghanistan?
Your answer should be very brief. 129.72. What is the difference between the highest and the lowest ODA received (in %) in Malaysia?
Offer a terse response. 0.44. What is the difference between the highest and the lowest ODA received (in %) of West Bank and Gaza?
Your answer should be very brief. 103.15. 